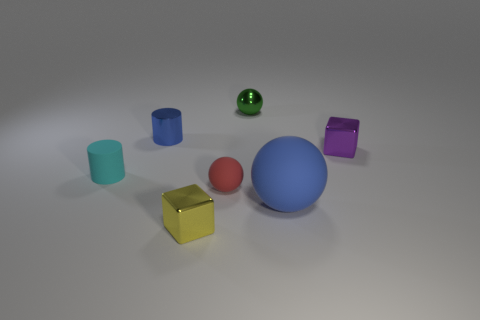How many small matte things have the same color as the matte cylinder?
Your answer should be very brief. 0. How many things are yellow metal objects or objects that are in front of the blue metallic cylinder?
Your answer should be very brief. 5. What color is the shiny sphere?
Provide a succinct answer. Green. There is a metallic thing in front of the red thing; what color is it?
Provide a short and direct response. Yellow. There is a rubber thing right of the small red thing; how many tiny metallic cylinders are on the right side of it?
Offer a very short reply. 0. There is a blue matte ball; is it the same size as the metal cylinder that is behind the yellow cube?
Your answer should be compact. No. Are there any other green shiny balls of the same size as the green ball?
Provide a short and direct response. No. What number of things are either tiny yellow metallic cubes or blue balls?
Provide a succinct answer. 2. Do the sphere that is behind the cyan matte object and the thing in front of the large rubber sphere have the same size?
Offer a terse response. Yes. Are there any red objects that have the same shape as the yellow shiny object?
Offer a terse response. No. 